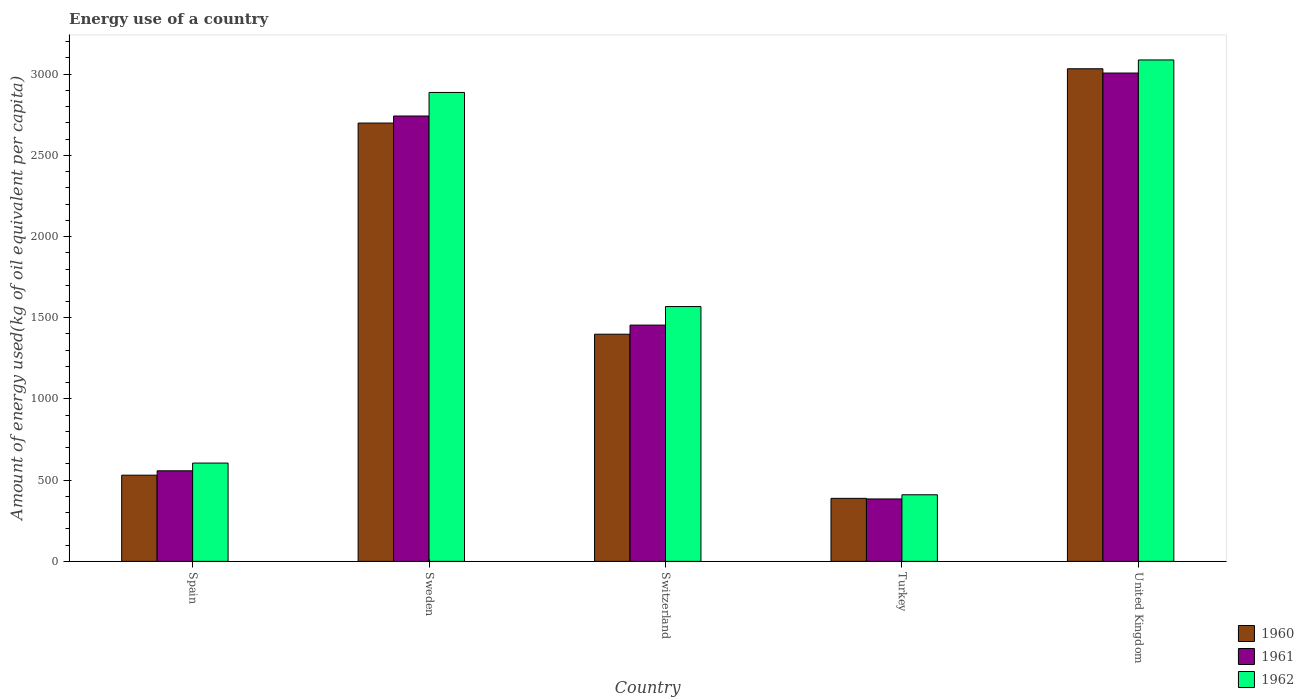Are the number of bars per tick equal to the number of legend labels?
Provide a succinct answer. Yes. How many bars are there on the 1st tick from the left?
Offer a very short reply. 3. How many bars are there on the 3rd tick from the right?
Keep it short and to the point. 3. What is the label of the 3rd group of bars from the left?
Make the answer very short. Switzerland. In how many cases, is the number of bars for a given country not equal to the number of legend labels?
Your answer should be very brief. 0. What is the amount of energy used in in 1960 in Sweden?
Provide a short and direct response. 2698.79. Across all countries, what is the maximum amount of energy used in in 1960?
Keep it short and to the point. 3033.05. Across all countries, what is the minimum amount of energy used in in 1961?
Your answer should be compact. 384.35. In which country was the amount of energy used in in 1962 minimum?
Provide a succinct answer. Turkey. What is the total amount of energy used in in 1962 in the graph?
Your response must be concise. 8558.73. What is the difference between the amount of energy used in in 1962 in Spain and that in United Kingdom?
Your answer should be very brief. -2482.12. What is the difference between the amount of energy used in in 1961 in Spain and the amount of energy used in in 1962 in Turkey?
Keep it short and to the point. 147.58. What is the average amount of energy used in in 1962 per country?
Your response must be concise. 1711.75. What is the difference between the amount of energy used in of/in 1960 and amount of energy used in of/in 1962 in Sweden?
Make the answer very short. -188.44. In how many countries, is the amount of energy used in in 1961 greater than 3100 kg?
Offer a very short reply. 0. What is the ratio of the amount of energy used in in 1960 in Spain to that in Sweden?
Provide a short and direct response. 0.2. Is the difference between the amount of energy used in in 1960 in Switzerland and United Kingdom greater than the difference between the amount of energy used in in 1962 in Switzerland and United Kingdom?
Your answer should be compact. No. What is the difference between the highest and the second highest amount of energy used in in 1960?
Provide a short and direct response. 334.26. What is the difference between the highest and the lowest amount of energy used in in 1961?
Offer a terse response. 2622.4. What does the 1st bar from the left in Switzerland represents?
Your response must be concise. 1960. Are all the bars in the graph horizontal?
Ensure brevity in your answer.  No. Are the values on the major ticks of Y-axis written in scientific E-notation?
Your answer should be very brief. No. Does the graph contain grids?
Your answer should be very brief. No. What is the title of the graph?
Ensure brevity in your answer.  Energy use of a country. What is the label or title of the Y-axis?
Your answer should be compact. Amount of energy used(kg of oil equivalent per capita). What is the Amount of energy used(kg of oil equivalent per capita) of 1960 in Spain?
Your answer should be very brief. 530.66. What is the Amount of energy used(kg of oil equivalent per capita) in 1961 in Spain?
Make the answer very short. 557.6. What is the Amount of energy used(kg of oil equivalent per capita) in 1962 in Spain?
Give a very brief answer. 605.22. What is the Amount of energy used(kg of oil equivalent per capita) of 1960 in Sweden?
Your answer should be compact. 2698.79. What is the Amount of energy used(kg of oil equivalent per capita) in 1961 in Sweden?
Your answer should be compact. 2742.12. What is the Amount of energy used(kg of oil equivalent per capita) in 1962 in Sweden?
Your answer should be compact. 2887.24. What is the Amount of energy used(kg of oil equivalent per capita) of 1960 in Switzerland?
Provide a succinct answer. 1398.65. What is the Amount of energy used(kg of oil equivalent per capita) in 1961 in Switzerland?
Your answer should be compact. 1454.76. What is the Amount of energy used(kg of oil equivalent per capita) in 1962 in Switzerland?
Provide a succinct answer. 1568.91. What is the Amount of energy used(kg of oil equivalent per capita) in 1960 in Turkey?
Your answer should be very brief. 387.97. What is the Amount of energy used(kg of oil equivalent per capita) in 1961 in Turkey?
Ensure brevity in your answer.  384.35. What is the Amount of energy used(kg of oil equivalent per capita) of 1962 in Turkey?
Offer a terse response. 410.02. What is the Amount of energy used(kg of oil equivalent per capita) of 1960 in United Kingdom?
Keep it short and to the point. 3033.05. What is the Amount of energy used(kg of oil equivalent per capita) in 1961 in United Kingdom?
Make the answer very short. 3006.75. What is the Amount of energy used(kg of oil equivalent per capita) in 1962 in United Kingdom?
Your answer should be very brief. 3087.34. Across all countries, what is the maximum Amount of energy used(kg of oil equivalent per capita) of 1960?
Make the answer very short. 3033.05. Across all countries, what is the maximum Amount of energy used(kg of oil equivalent per capita) in 1961?
Your answer should be very brief. 3006.75. Across all countries, what is the maximum Amount of energy used(kg of oil equivalent per capita) in 1962?
Provide a succinct answer. 3087.34. Across all countries, what is the minimum Amount of energy used(kg of oil equivalent per capita) of 1960?
Provide a succinct answer. 387.97. Across all countries, what is the minimum Amount of energy used(kg of oil equivalent per capita) in 1961?
Give a very brief answer. 384.35. Across all countries, what is the minimum Amount of energy used(kg of oil equivalent per capita) in 1962?
Your answer should be compact. 410.02. What is the total Amount of energy used(kg of oil equivalent per capita) in 1960 in the graph?
Offer a very short reply. 8049.13. What is the total Amount of energy used(kg of oil equivalent per capita) of 1961 in the graph?
Your response must be concise. 8145.57. What is the total Amount of energy used(kg of oil equivalent per capita) in 1962 in the graph?
Keep it short and to the point. 8558.73. What is the difference between the Amount of energy used(kg of oil equivalent per capita) of 1960 in Spain and that in Sweden?
Keep it short and to the point. -2168.13. What is the difference between the Amount of energy used(kg of oil equivalent per capita) in 1961 in Spain and that in Sweden?
Offer a very short reply. -2184.52. What is the difference between the Amount of energy used(kg of oil equivalent per capita) in 1962 in Spain and that in Sweden?
Offer a terse response. -2282.01. What is the difference between the Amount of energy used(kg of oil equivalent per capita) of 1960 in Spain and that in Switzerland?
Your answer should be very brief. -867.99. What is the difference between the Amount of energy used(kg of oil equivalent per capita) in 1961 in Spain and that in Switzerland?
Provide a succinct answer. -897.16. What is the difference between the Amount of energy used(kg of oil equivalent per capita) in 1962 in Spain and that in Switzerland?
Make the answer very short. -963.69. What is the difference between the Amount of energy used(kg of oil equivalent per capita) in 1960 in Spain and that in Turkey?
Provide a succinct answer. 142.69. What is the difference between the Amount of energy used(kg of oil equivalent per capita) in 1961 in Spain and that in Turkey?
Offer a terse response. 173.25. What is the difference between the Amount of energy used(kg of oil equivalent per capita) in 1962 in Spain and that in Turkey?
Your response must be concise. 195.2. What is the difference between the Amount of energy used(kg of oil equivalent per capita) in 1960 in Spain and that in United Kingdom?
Provide a succinct answer. -2502.39. What is the difference between the Amount of energy used(kg of oil equivalent per capita) in 1961 in Spain and that in United Kingdom?
Your answer should be compact. -2449.15. What is the difference between the Amount of energy used(kg of oil equivalent per capita) in 1962 in Spain and that in United Kingdom?
Your answer should be compact. -2482.12. What is the difference between the Amount of energy used(kg of oil equivalent per capita) of 1960 in Sweden and that in Switzerland?
Ensure brevity in your answer.  1300.14. What is the difference between the Amount of energy used(kg of oil equivalent per capita) in 1961 in Sweden and that in Switzerland?
Provide a short and direct response. 1287.37. What is the difference between the Amount of energy used(kg of oil equivalent per capita) of 1962 in Sweden and that in Switzerland?
Your answer should be compact. 1318.33. What is the difference between the Amount of energy used(kg of oil equivalent per capita) of 1960 in Sweden and that in Turkey?
Give a very brief answer. 2310.82. What is the difference between the Amount of energy used(kg of oil equivalent per capita) of 1961 in Sweden and that in Turkey?
Your answer should be very brief. 2357.78. What is the difference between the Amount of energy used(kg of oil equivalent per capita) of 1962 in Sweden and that in Turkey?
Your response must be concise. 2477.21. What is the difference between the Amount of energy used(kg of oil equivalent per capita) of 1960 in Sweden and that in United Kingdom?
Offer a very short reply. -334.26. What is the difference between the Amount of energy used(kg of oil equivalent per capita) of 1961 in Sweden and that in United Kingdom?
Ensure brevity in your answer.  -264.62. What is the difference between the Amount of energy used(kg of oil equivalent per capita) of 1962 in Sweden and that in United Kingdom?
Make the answer very short. -200.11. What is the difference between the Amount of energy used(kg of oil equivalent per capita) of 1960 in Switzerland and that in Turkey?
Your answer should be compact. 1010.68. What is the difference between the Amount of energy used(kg of oil equivalent per capita) in 1961 in Switzerland and that in Turkey?
Offer a terse response. 1070.41. What is the difference between the Amount of energy used(kg of oil equivalent per capita) of 1962 in Switzerland and that in Turkey?
Your answer should be compact. 1158.89. What is the difference between the Amount of energy used(kg of oil equivalent per capita) in 1960 in Switzerland and that in United Kingdom?
Provide a succinct answer. -1634.4. What is the difference between the Amount of energy used(kg of oil equivalent per capita) in 1961 in Switzerland and that in United Kingdom?
Provide a succinct answer. -1551.99. What is the difference between the Amount of energy used(kg of oil equivalent per capita) of 1962 in Switzerland and that in United Kingdom?
Your answer should be very brief. -1518.43. What is the difference between the Amount of energy used(kg of oil equivalent per capita) in 1960 in Turkey and that in United Kingdom?
Offer a terse response. -2645.08. What is the difference between the Amount of energy used(kg of oil equivalent per capita) of 1961 in Turkey and that in United Kingdom?
Your response must be concise. -2622.4. What is the difference between the Amount of energy used(kg of oil equivalent per capita) of 1962 in Turkey and that in United Kingdom?
Offer a terse response. -2677.32. What is the difference between the Amount of energy used(kg of oil equivalent per capita) of 1960 in Spain and the Amount of energy used(kg of oil equivalent per capita) of 1961 in Sweden?
Make the answer very short. -2211.46. What is the difference between the Amount of energy used(kg of oil equivalent per capita) of 1960 in Spain and the Amount of energy used(kg of oil equivalent per capita) of 1962 in Sweden?
Your answer should be very brief. -2356.57. What is the difference between the Amount of energy used(kg of oil equivalent per capita) of 1961 in Spain and the Amount of energy used(kg of oil equivalent per capita) of 1962 in Sweden?
Offer a very short reply. -2329.64. What is the difference between the Amount of energy used(kg of oil equivalent per capita) in 1960 in Spain and the Amount of energy used(kg of oil equivalent per capita) in 1961 in Switzerland?
Your response must be concise. -924.09. What is the difference between the Amount of energy used(kg of oil equivalent per capita) in 1960 in Spain and the Amount of energy used(kg of oil equivalent per capita) in 1962 in Switzerland?
Offer a very short reply. -1038.25. What is the difference between the Amount of energy used(kg of oil equivalent per capita) in 1961 in Spain and the Amount of energy used(kg of oil equivalent per capita) in 1962 in Switzerland?
Your answer should be compact. -1011.31. What is the difference between the Amount of energy used(kg of oil equivalent per capita) of 1960 in Spain and the Amount of energy used(kg of oil equivalent per capita) of 1961 in Turkey?
Offer a very short reply. 146.32. What is the difference between the Amount of energy used(kg of oil equivalent per capita) in 1960 in Spain and the Amount of energy used(kg of oil equivalent per capita) in 1962 in Turkey?
Provide a short and direct response. 120.64. What is the difference between the Amount of energy used(kg of oil equivalent per capita) of 1961 in Spain and the Amount of energy used(kg of oil equivalent per capita) of 1962 in Turkey?
Provide a succinct answer. 147.58. What is the difference between the Amount of energy used(kg of oil equivalent per capita) of 1960 in Spain and the Amount of energy used(kg of oil equivalent per capita) of 1961 in United Kingdom?
Provide a succinct answer. -2476.08. What is the difference between the Amount of energy used(kg of oil equivalent per capita) in 1960 in Spain and the Amount of energy used(kg of oil equivalent per capita) in 1962 in United Kingdom?
Make the answer very short. -2556.68. What is the difference between the Amount of energy used(kg of oil equivalent per capita) in 1961 in Spain and the Amount of energy used(kg of oil equivalent per capita) in 1962 in United Kingdom?
Your answer should be compact. -2529.74. What is the difference between the Amount of energy used(kg of oil equivalent per capita) of 1960 in Sweden and the Amount of energy used(kg of oil equivalent per capita) of 1961 in Switzerland?
Offer a terse response. 1244.04. What is the difference between the Amount of energy used(kg of oil equivalent per capita) in 1960 in Sweden and the Amount of energy used(kg of oil equivalent per capita) in 1962 in Switzerland?
Provide a succinct answer. 1129.88. What is the difference between the Amount of energy used(kg of oil equivalent per capita) of 1961 in Sweden and the Amount of energy used(kg of oil equivalent per capita) of 1962 in Switzerland?
Offer a very short reply. 1173.21. What is the difference between the Amount of energy used(kg of oil equivalent per capita) in 1960 in Sweden and the Amount of energy used(kg of oil equivalent per capita) in 1961 in Turkey?
Make the answer very short. 2314.45. What is the difference between the Amount of energy used(kg of oil equivalent per capita) of 1960 in Sweden and the Amount of energy used(kg of oil equivalent per capita) of 1962 in Turkey?
Make the answer very short. 2288.77. What is the difference between the Amount of energy used(kg of oil equivalent per capita) in 1961 in Sweden and the Amount of energy used(kg of oil equivalent per capita) in 1962 in Turkey?
Provide a succinct answer. 2332.1. What is the difference between the Amount of energy used(kg of oil equivalent per capita) in 1960 in Sweden and the Amount of energy used(kg of oil equivalent per capita) in 1961 in United Kingdom?
Your response must be concise. -307.96. What is the difference between the Amount of energy used(kg of oil equivalent per capita) in 1960 in Sweden and the Amount of energy used(kg of oil equivalent per capita) in 1962 in United Kingdom?
Keep it short and to the point. -388.55. What is the difference between the Amount of energy used(kg of oil equivalent per capita) in 1961 in Sweden and the Amount of energy used(kg of oil equivalent per capita) in 1962 in United Kingdom?
Your answer should be very brief. -345.22. What is the difference between the Amount of energy used(kg of oil equivalent per capita) of 1960 in Switzerland and the Amount of energy used(kg of oil equivalent per capita) of 1961 in Turkey?
Ensure brevity in your answer.  1014.31. What is the difference between the Amount of energy used(kg of oil equivalent per capita) in 1960 in Switzerland and the Amount of energy used(kg of oil equivalent per capita) in 1962 in Turkey?
Give a very brief answer. 988.63. What is the difference between the Amount of energy used(kg of oil equivalent per capita) of 1961 in Switzerland and the Amount of energy used(kg of oil equivalent per capita) of 1962 in Turkey?
Give a very brief answer. 1044.73. What is the difference between the Amount of energy used(kg of oil equivalent per capita) of 1960 in Switzerland and the Amount of energy used(kg of oil equivalent per capita) of 1961 in United Kingdom?
Your response must be concise. -1608.09. What is the difference between the Amount of energy used(kg of oil equivalent per capita) of 1960 in Switzerland and the Amount of energy used(kg of oil equivalent per capita) of 1962 in United Kingdom?
Your answer should be very brief. -1688.69. What is the difference between the Amount of energy used(kg of oil equivalent per capita) in 1961 in Switzerland and the Amount of energy used(kg of oil equivalent per capita) in 1962 in United Kingdom?
Make the answer very short. -1632.59. What is the difference between the Amount of energy used(kg of oil equivalent per capita) of 1960 in Turkey and the Amount of energy used(kg of oil equivalent per capita) of 1961 in United Kingdom?
Your answer should be compact. -2618.78. What is the difference between the Amount of energy used(kg of oil equivalent per capita) of 1960 in Turkey and the Amount of energy used(kg of oil equivalent per capita) of 1962 in United Kingdom?
Give a very brief answer. -2699.37. What is the difference between the Amount of energy used(kg of oil equivalent per capita) of 1961 in Turkey and the Amount of energy used(kg of oil equivalent per capita) of 1962 in United Kingdom?
Give a very brief answer. -2703. What is the average Amount of energy used(kg of oil equivalent per capita) in 1960 per country?
Offer a terse response. 1609.83. What is the average Amount of energy used(kg of oil equivalent per capita) of 1961 per country?
Your answer should be compact. 1629.11. What is the average Amount of energy used(kg of oil equivalent per capita) in 1962 per country?
Ensure brevity in your answer.  1711.75. What is the difference between the Amount of energy used(kg of oil equivalent per capita) of 1960 and Amount of energy used(kg of oil equivalent per capita) of 1961 in Spain?
Your answer should be compact. -26.93. What is the difference between the Amount of energy used(kg of oil equivalent per capita) of 1960 and Amount of energy used(kg of oil equivalent per capita) of 1962 in Spain?
Provide a short and direct response. -74.56. What is the difference between the Amount of energy used(kg of oil equivalent per capita) in 1961 and Amount of energy used(kg of oil equivalent per capita) in 1962 in Spain?
Provide a short and direct response. -47.62. What is the difference between the Amount of energy used(kg of oil equivalent per capita) of 1960 and Amount of energy used(kg of oil equivalent per capita) of 1961 in Sweden?
Keep it short and to the point. -43.33. What is the difference between the Amount of energy used(kg of oil equivalent per capita) of 1960 and Amount of energy used(kg of oil equivalent per capita) of 1962 in Sweden?
Your response must be concise. -188.44. What is the difference between the Amount of energy used(kg of oil equivalent per capita) in 1961 and Amount of energy used(kg of oil equivalent per capita) in 1962 in Sweden?
Provide a succinct answer. -145.11. What is the difference between the Amount of energy used(kg of oil equivalent per capita) of 1960 and Amount of energy used(kg of oil equivalent per capita) of 1961 in Switzerland?
Provide a succinct answer. -56.1. What is the difference between the Amount of energy used(kg of oil equivalent per capita) in 1960 and Amount of energy used(kg of oil equivalent per capita) in 1962 in Switzerland?
Your answer should be very brief. -170.26. What is the difference between the Amount of energy used(kg of oil equivalent per capita) of 1961 and Amount of energy used(kg of oil equivalent per capita) of 1962 in Switzerland?
Your answer should be compact. -114.16. What is the difference between the Amount of energy used(kg of oil equivalent per capita) in 1960 and Amount of energy used(kg of oil equivalent per capita) in 1961 in Turkey?
Offer a very short reply. 3.62. What is the difference between the Amount of energy used(kg of oil equivalent per capita) of 1960 and Amount of energy used(kg of oil equivalent per capita) of 1962 in Turkey?
Give a very brief answer. -22.05. What is the difference between the Amount of energy used(kg of oil equivalent per capita) of 1961 and Amount of energy used(kg of oil equivalent per capita) of 1962 in Turkey?
Offer a very short reply. -25.68. What is the difference between the Amount of energy used(kg of oil equivalent per capita) in 1960 and Amount of energy used(kg of oil equivalent per capita) in 1961 in United Kingdom?
Provide a short and direct response. 26.3. What is the difference between the Amount of energy used(kg of oil equivalent per capita) of 1960 and Amount of energy used(kg of oil equivalent per capita) of 1962 in United Kingdom?
Provide a succinct answer. -54.29. What is the difference between the Amount of energy used(kg of oil equivalent per capita) in 1961 and Amount of energy used(kg of oil equivalent per capita) in 1962 in United Kingdom?
Make the answer very short. -80.59. What is the ratio of the Amount of energy used(kg of oil equivalent per capita) of 1960 in Spain to that in Sweden?
Offer a very short reply. 0.2. What is the ratio of the Amount of energy used(kg of oil equivalent per capita) in 1961 in Spain to that in Sweden?
Offer a very short reply. 0.2. What is the ratio of the Amount of energy used(kg of oil equivalent per capita) in 1962 in Spain to that in Sweden?
Ensure brevity in your answer.  0.21. What is the ratio of the Amount of energy used(kg of oil equivalent per capita) of 1960 in Spain to that in Switzerland?
Offer a very short reply. 0.38. What is the ratio of the Amount of energy used(kg of oil equivalent per capita) in 1961 in Spain to that in Switzerland?
Your answer should be compact. 0.38. What is the ratio of the Amount of energy used(kg of oil equivalent per capita) of 1962 in Spain to that in Switzerland?
Your response must be concise. 0.39. What is the ratio of the Amount of energy used(kg of oil equivalent per capita) of 1960 in Spain to that in Turkey?
Your response must be concise. 1.37. What is the ratio of the Amount of energy used(kg of oil equivalent per capita) in 1961 in Spain to that in Turkey?
Provide a short and direct response. 1.45. What is the ratio of the Amount of energy used(kg of oil equivalent per capita) of 1962 in Spain to that in Turkey?
Keep it short and to the point. 1.48. What is the ratio of the Amount of energy used(kg of oil equivalent per capita) of 1960 in Spain to that in United Kingdom?
Your response must be concise. 0.17. What is the ratio of the Amount of energy used(kg of oil equivalent per capita) in 1961 in Spain to that in United Kingdom?
Provide a succinct answer. 0.19. What is the ratio of the Amount of energy used(kg of oil equivalent per capita) in 1962 in Spain to that in United Kingdom?
Ensure brevity in your answer.  0.2. What is the ratio of the Amount of energy used(kg of oil equivalent per capita) of 1960 in Sweden to that in Switzerland?
Keep it short and to the point. 1.93. What is the ratio of the Amount of energy used(kg of oil equivalent per capita) of 1961 in Sweden to that in Switzerland?
Your answer should be very brief. 1.88. What is the ratio of the Amount of energy used(kg of oil equivalent per capita) of 1962 in Sweden to that in Switzerland?
Offer a very short reply. 1.84. What is the ratio of the Amount of energy used(kg of oil equivalent per capita) of 1960 in Sweden to that in Turkey?
Make the answer very short. 6.96. What is the ratio of the Amount of energy used(kg of oil equivalent per capita) of 1961 in Sweden to that in Turkey?
Your answer should be very brief. 7.13. What is the ratio of the Amount of energy used(kg of oil equivalent per capita) of 1962 in Sweden to that in Turkey?
Your response must be concise. 7.04. What is the ratio of the Amount of energy used(kg of oil equivalent per capita) of 1960 in Sweden to that in United Kingdom?
Provide a short and direct response. 0.89. What is the ratio of the Amount of energy used(kg of oil equivalent per capita) of 1961 in Sweden to that in United Kingdom?
Provide a succinct answer. 0.91. What is the ratio of the Amount of energy used(kg of oil equivalent per capita) of 1962 in Sweden to that in United Kingdom?
Offer a very short reply. 0.94. What is the ratio of the Amount of energy used(kg of oil equivalent per capita) in 1960 in Switzerland to that in Turkey?
Give a very brief answer. 3.61. What is the ratio of the Amount of energy used(kg of oil equivalent per capita) of 1961 in Switzerland to that in Turkey?
Make the answer very short. 3.79. What is the ratio of the Amount of energy used(kg of oil equivalent per capita) of 1962 in Switzerland to that in Turkey?
Offer a terse response. 3.83. What is the ratio of the Amount of energy used(kg of oil equivalent per capita) in 1960 in Switzerland to that in United Kingdom?
Keep it short and to the point. 0.46. What is the ratio of the Amount of energy used(kg of oil equivalent per capita) of 1961 in Switzerland to that in United Kingdom?
Your answer should be compact. 0.48. What is the ratio of the Amount of energy used(kg of oil equivalent per capita) in 1962 in Switzerland to that in United Kingdom?
Give a very brief answer. 0.51. What is the ratio of the Amount of energy used(kg of oil equivalent per capita) of 1960 in Turkey to that in United Kingdom?
Provide a short and direct response. 0.13. What is the ratio of the Amount of energy used(kg of oil equivalent per capita) in 1961 in Turkey to that in United Kingdom?
Give a very brief answer. 0.13. What is the ratio of the Amount of energy used(kg of oil equivalent per capita) of 1962 in Turkey to that in United Kingdom?
Keep it short and to the point. 0.13. What is the difference between the highest and the second highest Amount of energy used(kg of oil equivalent per capita) of 1960?
Make the answer very short. 334.26. What is the difference between the highest and the second highest Amount of energy used(kg of oil equivalent per capita) of 1961?
Provide a short and direct response. 264.62. What is the difference between the highest and the second highest Amount of energy used(kg of oil equivalent per capita) of 1962?
Offer a very short reply. 200.11. What is the difference between the highest and the lowest Amount of energy used(kg of oil equivalent per capita) of 1960?
Provide a short and direct response. 2645.08. What is the difference between the highest and the lowest Amount of energy used(kg of oil equivalent per capita) in 1961?
Offer a terse response. 2622.4. What is the difference between the highest and the lowest Amount of energy used(kg of oil equivalent per capita) of 1962?
Offer a terse response. 2677.32. 